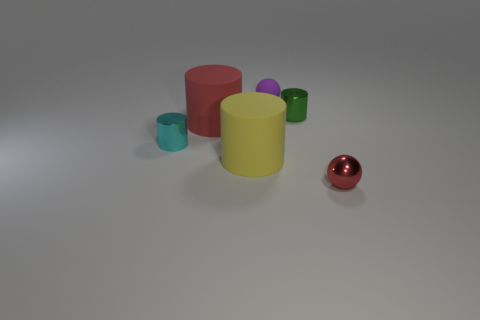Subtract all cyan metallic cylinders. How many cylinders are left? 3 Subtract all green cylinders. How many cylinders are left? 3 Add 1 balls. How many objects exist? 7 Subtract all brown cylinders. Subtract all green balls. How many cylinders are left? 4 Subtract all cylinders. How many objects are left? 2 Add 2 tiny red shiny balls. How many tiny red shiny balls exist? 3 Subtract 1 yellow cylinders. How many objects are left? 5 Subtract all purple rubber spheres. Subtract all cyan cylinders. How many objects are left? 4 Add 5 rubber balls. How many rubber balls are left? 6 